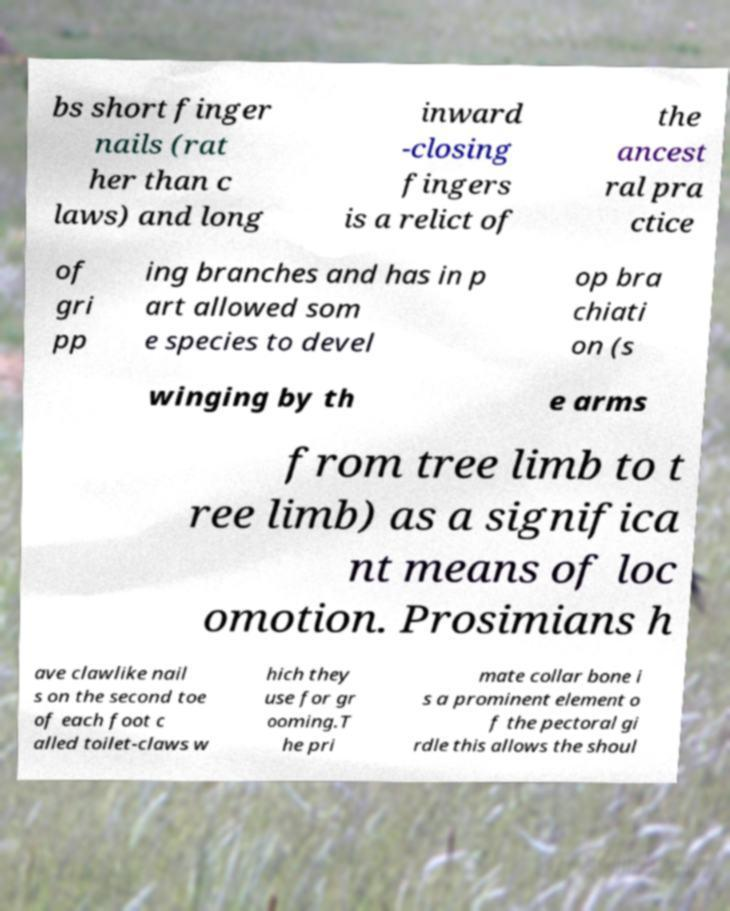What messages or text are displayed in this image? I need them in a readable, typed format. bs short finger nails (rat her than c laws) and long inward -closing fingers is a relict of the ancest ral pra ctice of gri pp ing branches and has in p art allowed som e species to devel op bra chiati on (s winging by th e arms from tree limb to t ree limb) as a significa nt means of loc omotion. Prosimians h ave clawlike nail s on the second toe of each foot c alled toilet-claws w hich they use for gr ooming.T he pri mate collar bone i s a prominent element o f the pectoral gi rdle this allows the shoul 